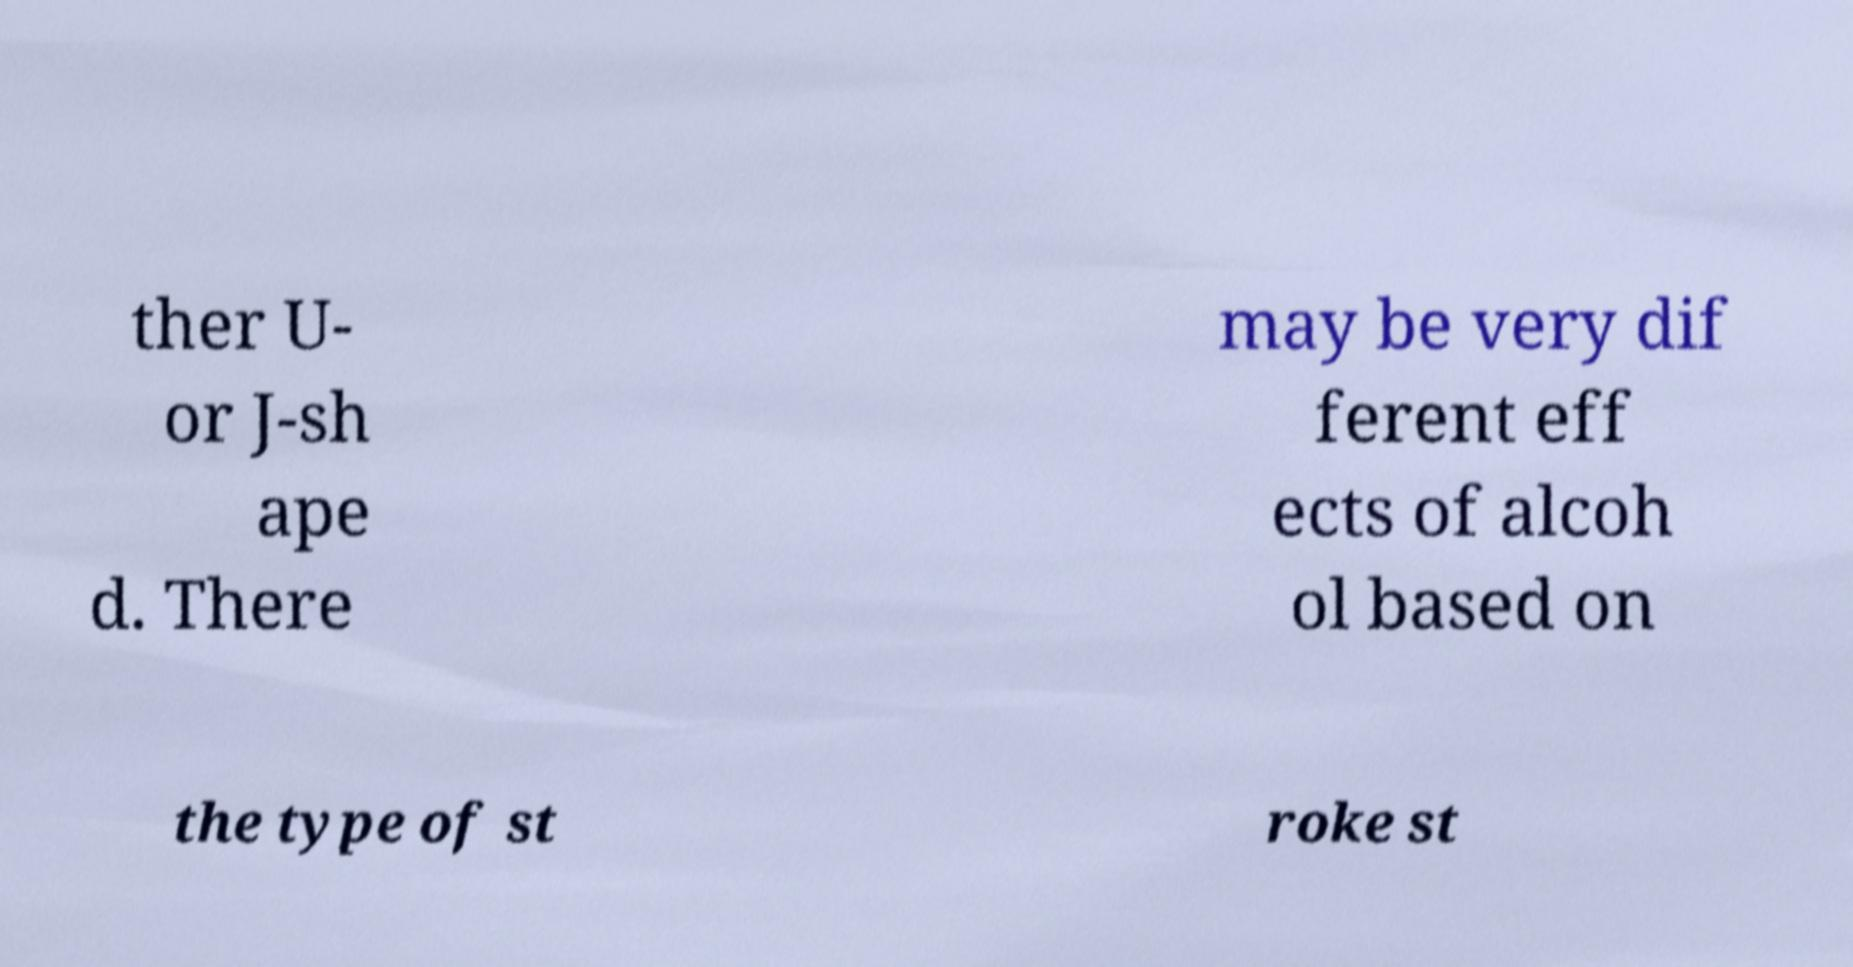Could you extract and type out the text from this image? ther U- or J-sh ape d. There may be very dif ferent eff ects of alcoh ol based on the type of st roke st 